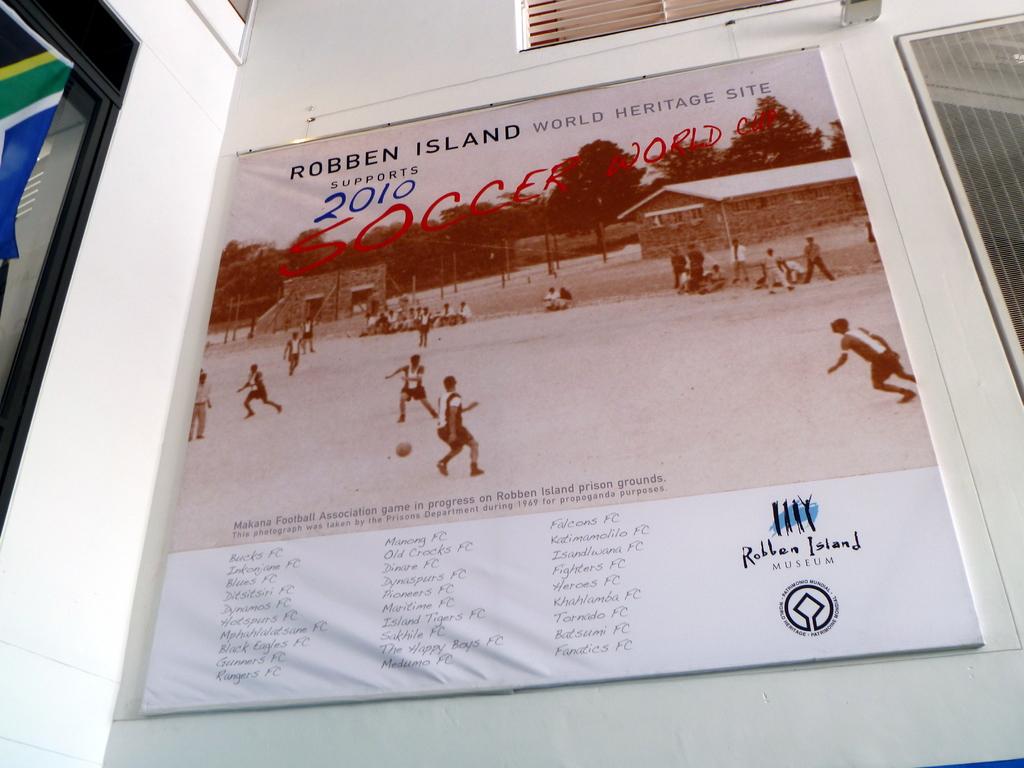Is there grass there or not?
Keep it short and to the point. No. What is the name of the museum?
Provide a succinct answer. Robben island. 